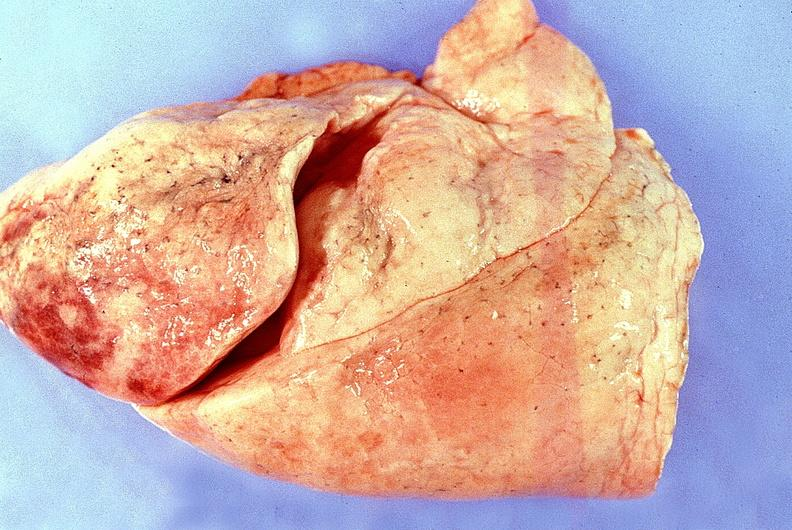s respiratory present?
Answer the question using a single word or phrase. Yes 